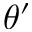Convert formula to latex. <formula><loc_0><loc_0><loc_500><loc_500>\theta ^ { \prime }</formula> 